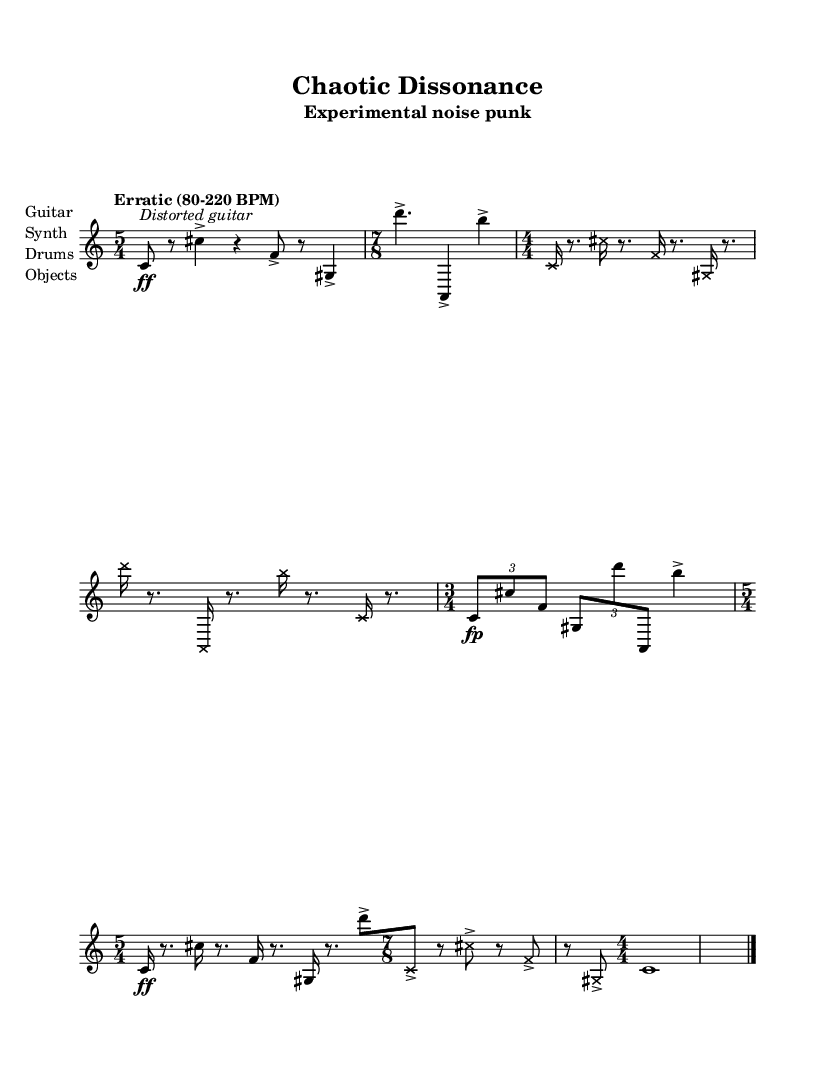What is the time signature of the introduction? The time signature of the introduction is displayed as 5/4 in the music sheet. It indicates that there are five beats in each measure, and the quarter note gets one beat.
Answer: 5/4 What dynamic marking is indicated at the beginning of the Noise Section A? The dynamic marking at the beginning of Noise Section A is ff, which stands for "fortissimo," meaning very loud. This is indicated right before the first note in that section.
Answer: fortissimo How many distinct time signatures are used in this piece? By examining the music sheet, the distinct time signatures present are 5/4, 7/8, 4/4, and 3/4. Counting these gives us four unique signatures used in this piece overall.
Answer: 4 What note style is employed in Noise Section A? In Noise Section A, the note style is designated as cross, indicating that the noteheads are drawn as crosses instead of traditional oval shapes for a stylistic effect.
Answer: cross Explain the tempo variation in the piece. The tempo is described as "Erratic (80-220 BPM)," illustrating that the tempo can change dramatically throughout the performance, varying from a slow beat at 80 beats per minute to a fast one at 220 beats per minute. This erratic nature reflects the unpredictable structure often found in experimental noise punk.
Answer: Erratic (80-220 BPM) What is the dynamic marking at the end of the piece? At the end of the piece, a dynamic marking of pp is present, representing "pianissimo," which indicates that the music should be played very softly. This is noted right before the final note in the outro section.
Answer: pianissimo What is the primary instrument stated in the score? The primary instrument indicated in the score is the guitar, which is listed first in the instrument names provided. This suggests that it is likely the focus of the musical texture throughout the piece.
Answer: Guitar 